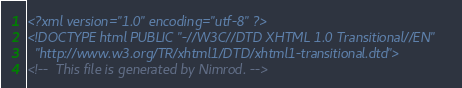<code> <loc_0><loc_0><loc_500><loc_500><_HTML_><?xml version="1.0" encoding="utf-8" ?>
<!DOCTYPE html PUBLIC "-//W3C//DTD XHTML 1.0 Transitional//EN"
  "http://www.w3.org/TR/xhtml1/DTD/xhtml1-transitional.dtd">
<!--  This file is generated by Nimrod. --></code> 